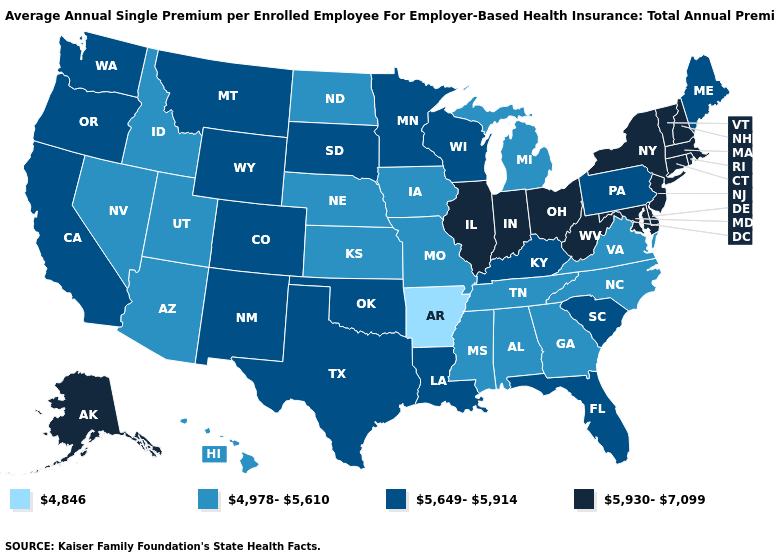Name the states that have a value in the range 5,930-7,099?
Give a very brief answer. Alaska, Connecticut, Delaware, Illinois, Indiana, Maryland, Massachusetts, New Hampshire, New Jersey, New York, Ohio, Rhode Island, Vermont, West Virginia. What is the lowest value in states that border Wyoming?
Short answer required. 4,978-5,610. Name the states that have a value in the range 4,978-5,610?
Give a very brief answer. Alabama, Arizona, Georgia, Hawaii, Idaho, Iowa, Kansas, Michigan, Mississippi, Missouri, Nebraska, Nevada, North Carolina, North Dakota, Tennessee, Utah, Virginia. What is the highest value in states that border Iowa?
Keep it brief. 5,930-7,099. Does California have a lower value than West Virginia?
Keep it brief. Yes. What is the highest value in the Northeast ?
Keep it brief. 5,930-7,099. Among the states that border Illinois , which have the highest value?
Short answer required. Indiana. Name the states that have a value in the range 5,649-5,914?
Short answer required. California, Colorado, Florida, Kentucky, Louisiana, Maine, Minnesota, Montana, New Mexico, Oklahoma, Oregon, Pennsylvania, South Carolina, South Dakota, Texas, Washington, Wisconsin, Wyoming. Name the states that have a value in the range 4,846?
Concise answer only. Arkansas. Does Colorado have the lowest value in the West?
Be succinct. No. Name the states that have a value in the range 5,649-5,914?
Concise answer only. California, Colorado, Florida, Kentucky, Louisiana, Maine, Minnesota, Montana, New Mexico, Oklahoma, Oregon, Pennsylvania, South Carolina, South Dakota, Texas, Washington, Wisconsin, Wyoming. Among the states that border Georgia , which have the lowest value?
Give a very brief answer. Alabama, North Carolina, Tennessee. Name the states that have a value in the range 5,930-7,099?
Write a very short answer. Alaska, Connecticut, Delaware, Illinois, Indiana, Maryland, Massachusetts, New Hampshire, New Jersey, New York, Ohio, Rhode Island, Vermont, West Virginia. Does Oklahoma have the lowest value in the USA?
Give a very brief answer. No. What is the highest value in the USA?
Answer briefly. 5,930-7,099. 